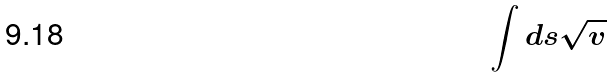Convert formula to latex. <formula><loc_0><loc_0><loc_500><loc_500>\int d s \sqrt { v }</formula> 